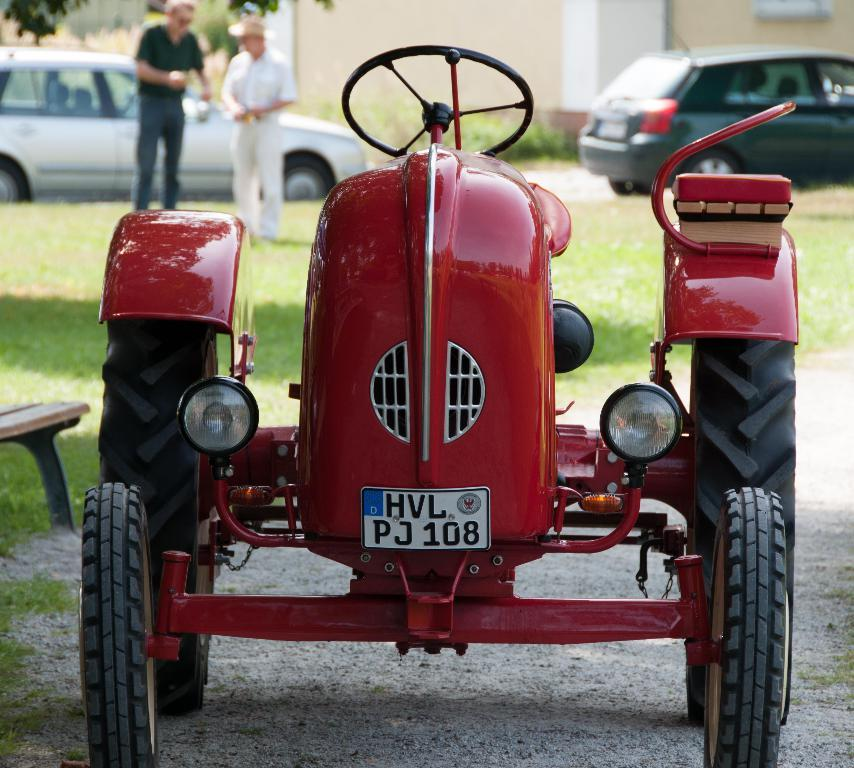What type of vehicle is in the image? There is a red tractor in the image. What are the two men doing in the image? The two men are standing on the grass. What can be seen on the road in the image? There are cars parked on the road. Can you tell me how many strangers are present in the image? The term "stranger" is subjective and cannot be definitively answered based on the image. However, there are two men present in the image, and they may or may not be strangers to the person viewing the image. 